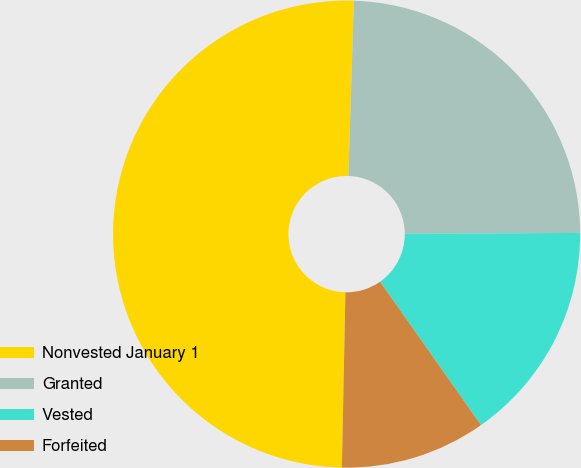<chart> <loc_0><loc_0><loc_500><loc_500><pie_chart><fcel>Nonvested January 1<fcel>Granted<fcel>Vested<fcel>Forfeited<nl><fcel>50.17%<fcel>24.42%<fcel>15.32%<fcel>10.08%<nl></chart> 